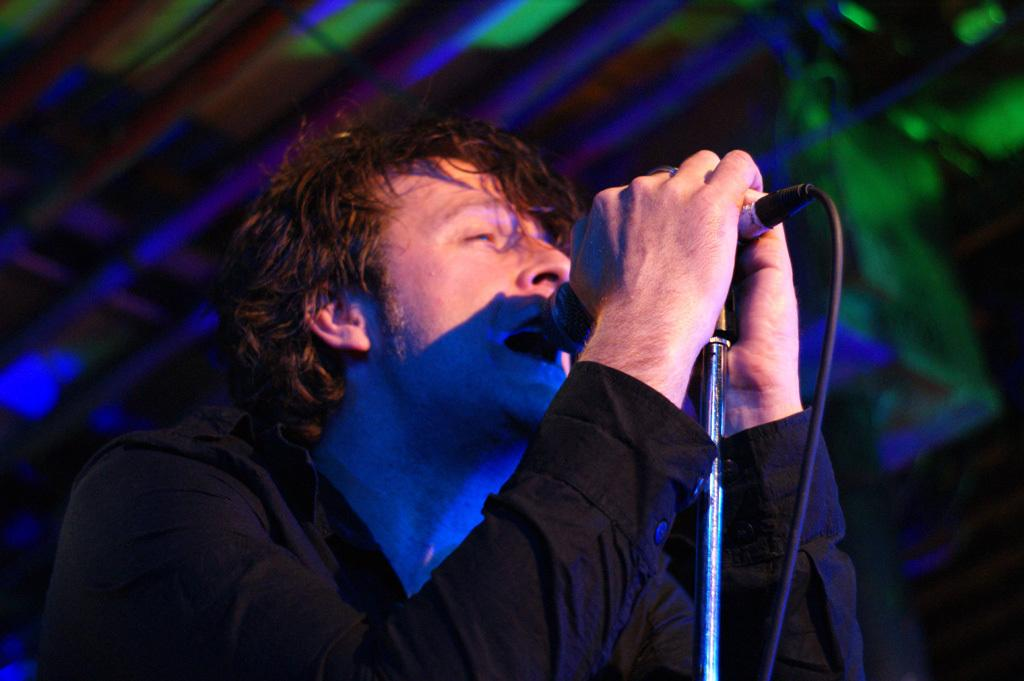What is the main subject of the image? The main subject of the image is a man. What is the man doing in the image? The man is singing in the image. What object is the man holding while singing? The man is holding a mic in the image. What year is depicted in the image? The image does not depict a specific year; it only shows a man singing with a mic. Can you describe the lake scene in the image? There is no lake scene present in the image; it only features a man singing with a mic. 